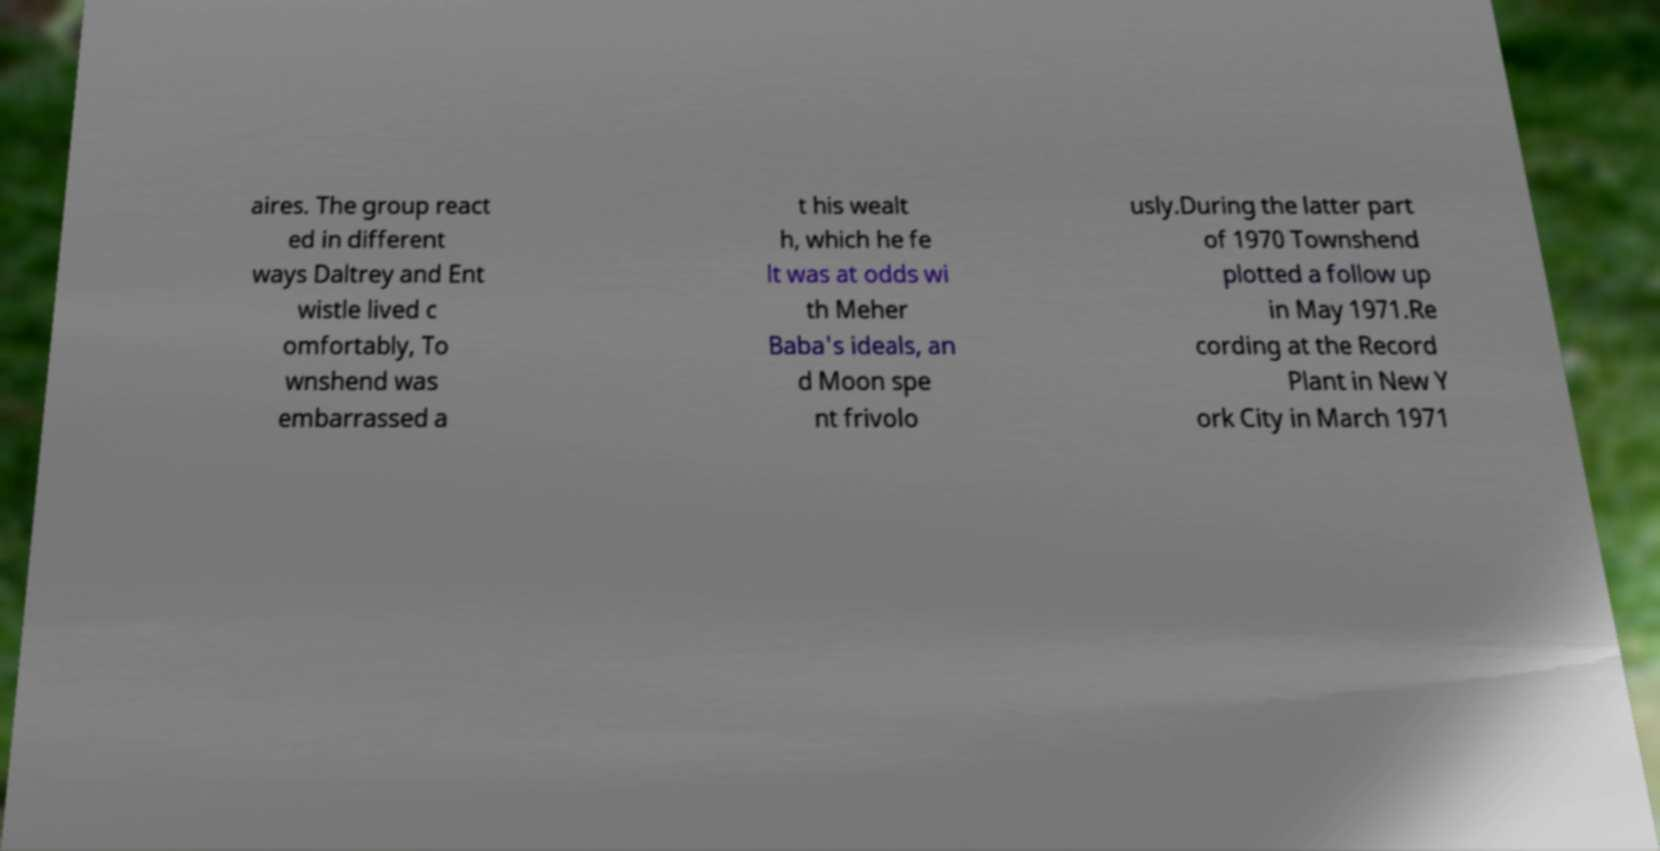Can you read and provide the text displayed in the image?This photo seems to have some interesting text. Can you extract and type it out for me? aires. The group react ed in different ways Daltrey and Ent wistle lived c omfortably, To wnshend was embarrassed a t his wealt h, which he fe lt was at odds wi th Meher Baba's ideals, an d Moon spe nt frivolo usly.During the latter part of 1970 Townshend plotted a follow up in May 1971.Re cording at the Record Plant in New Y ork City in March 1971 